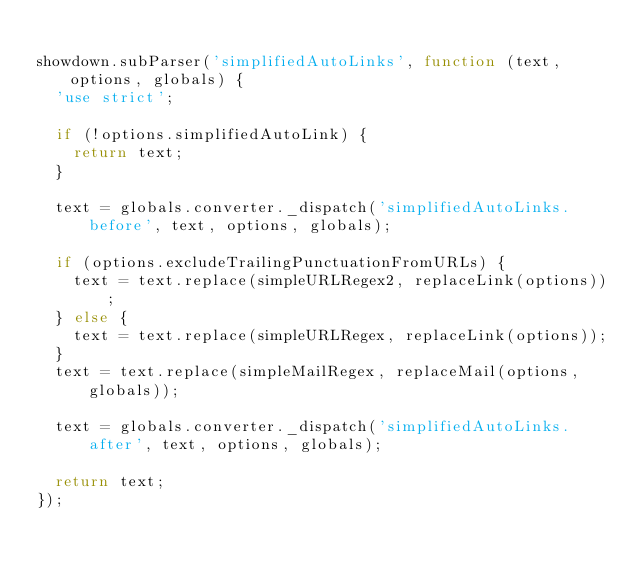<code> <loc_0><loc_0><loc_500><loc_500><_JavaScript_>
showdown.subParser('simplifiedAutoLinks', function (text, options, globals) {
  'use strict';

  if (!options.simplifiedAutoLink) {
    return text;
  }

  text = globals.converter._dispatch('simplifiedAutoLinks.before', text, options, globals);

  if (options.excludeTrailingPunctuationFromURLs) {
    text = text.replace(simpleURLRegex2, replaceLink(options));
  } else {
    text = text.replace(simpleURLRegex, replaceLink(options));
  }
  text = text.replace(simpleMailRegex, replaceMail(options, globals));

  text = globals.converter._dispatch('simplifiedAutoLinks.after', text, options, globals);

  return text;
});
</code> 